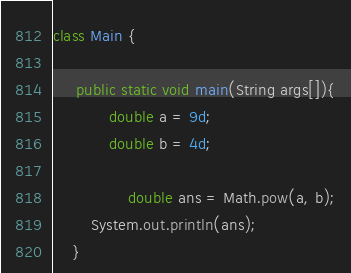<code> <loc_0><loc_0><loc_500><loc_500><_Java_>class Main {

	 public static void main(String args[]){
		    double a = 9d;
		    double b = 4d;

                double ans = Math.pow(a, b);
        System.out.println(ans);
    }</code> 